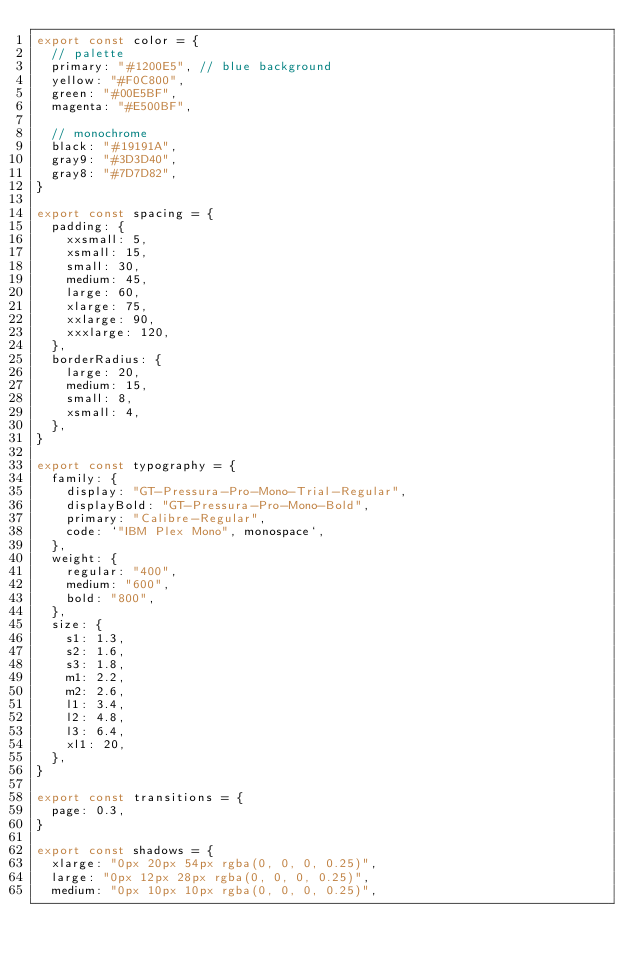Convert code to text. <code><loc_0><loc_0><loc_500><loc_500><_JavaScript_>export const color = {
  // palette
  primary: "#1200E5", // blue background
  yellow: "#F0C800",
  green: "#00E5BF",
  magenta: "#E500BF",

  // monochrome
  black: "#19191A",
  gray9: "#3D3D40",
  gray8: "#7D7D82",
}

export const spacing = {
  padding: {
    xxsmall: 5,
    xsmall: 15,
    small: 30,
    medium: 45,
    large: 60,
    xlarge: 75,
    xxlarge: 90,
    xxxlarge: 120,
  },
  borderRadius: {
    large: 20,
    medium: 15,
    small: 8,
    xsmall: 4,
  },
}

export const typography = {
  family: {
    display: "GT-Pressura-Pro-Mono-Trial-Regular",
    displayBold: "GT-Pressura-Pro-Mono-Bold",
    primary: "Calibre-Regular",
    code: `"IBM Plex Mono", monospace`,
  },
  weight: {
    regular: "400",
    medium: "600",
    bold: "800",
  },
  size: {
    s1: 1.3,
    s2: 1.6,
    s3: 1.8,
    m1: 2.2,
    m2: 2.6,
    l1: 3.4,
    l2: 4.8,
    l3: 6.4,
    xl1: 20,
  },
}

export const transitions = {
  page: 0.3,
}

export const shadows = {
  xlarge: "0px 20px 54px rgba(0, 0, 0, 0.25)",
  large: "0px 12px 28px rgba(0, 0, 0, 0.25)",
  medium: "0px 10px 10px rgba(0, 0, 0, 0.25)",</code> 